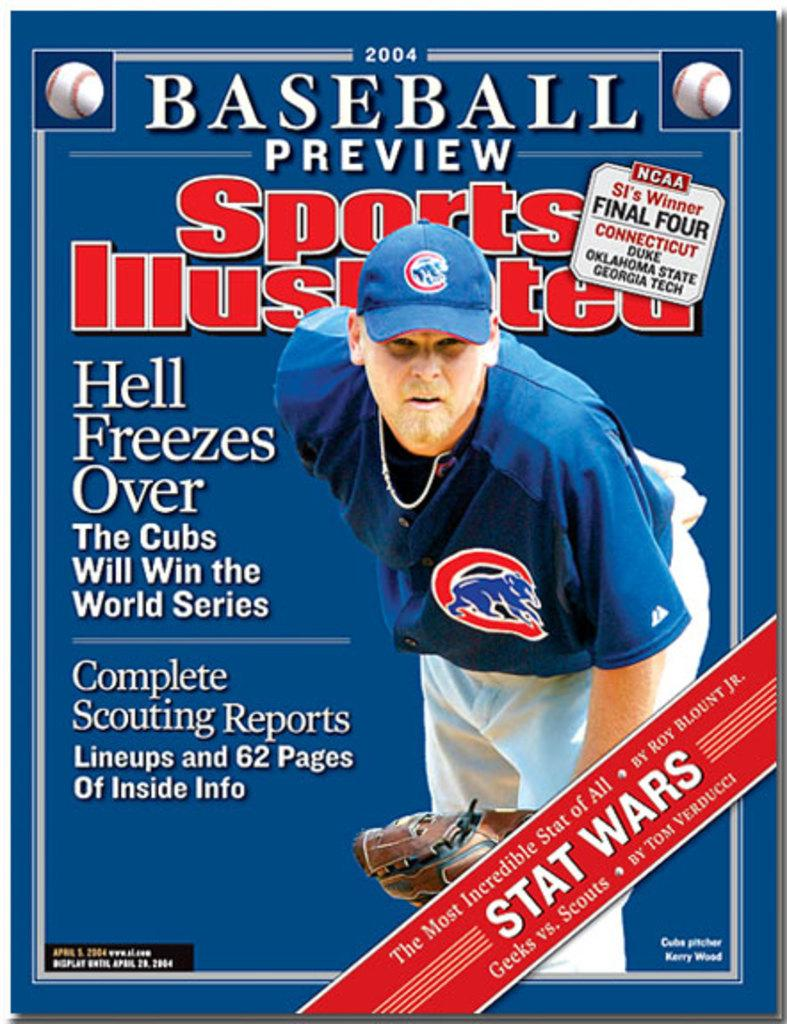<image>
Describe the image concisely. Sports Illustrated Magazine from 2004 highlight Baseball Preview. 